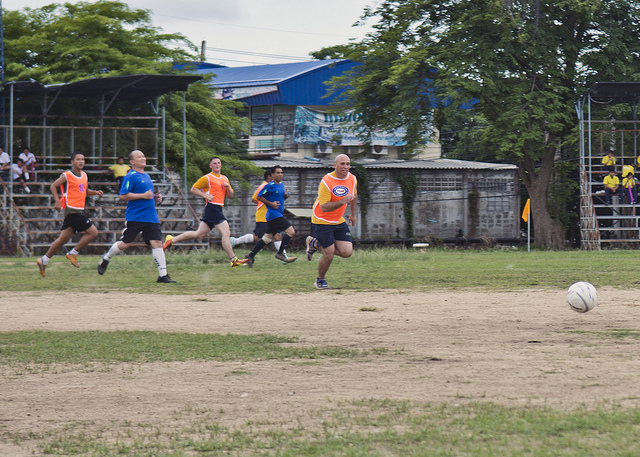<image>What animals are in the image? It is ambiguous. There might be no animals or humans in the image. Which team is winning? It's ambiguous which team is winning. It could be either the orange or blue team. What animals are in the image? I don't know what animals are in the image. It seems that there are no animals in the image and only humans. Which team is winning? It is ambiguous which team is winning. It can be seen both the orange team and the blue team. 